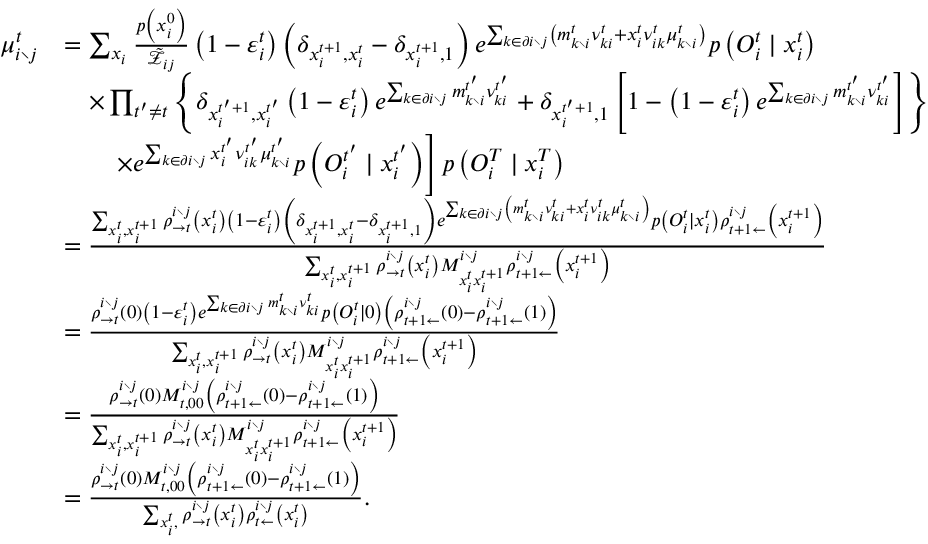Convert formula to latex. <formula><loc_0><loc_0><loc_500><loc_500>\begin{array} { r l } { \mu _ { i \ j } ^ { t } } & { = \sum _ { x _ { i } } \frac { p \left ( x _ { i } ^ { 0 } \right ) } { \tilde { \mathcal { Z } } _ { i j } } \left ( 1 - \varepsilon _ { i } ^ { t } \right ) \left ( \delta _ { x _ { i } ^ { t + 1 } , x _ { i } ^ { t } } - \delta _ { x _ { i } ^ { t + 1 } , 1 } \right ) e ^ { \sum _ { k \in \partial i \ j } \left ( m _ { k \ i } ^ { t } \nu _ { k i } ^ { t } + x _ { i } ^ { t } \nu _ { i k } ^ { t } \mu _ { k \ i } ^ { t } \right ) } p \left ( O _ { i } ^ { t } | x _ { i } ^ { t } \right ) } \\ & { \quad \times \prod _ { t ^ { \prime } \neq t } \left \{ \delta _ { x _ { i } ^ { t ^ { \prime } + 1 } , x _ { i } ^ { t ^ { \prime } } } \left ( 1 - \varepsilon _ { i } ^ { t } \right ) e ^ { \sum _ { k \in \partial i \ j } m _ { k \ i } ^ { t ^ { \prime } } \nu _ { k i } ^ { t ^ { \prime } } } + \delta _ { x _ { i } ^ { t ^ { \prime } + 1 } , 1 } \left [ 1 - \left ( 1 - \varepsilon _ { i } ^ { t } \right ) e ^ { \sum _ { k \in \partial i \ j } m _ { k \ i } ^ { t ^ { \prime } } \nu _ { k i } ^ { t ^ { \prime } } } \right ] \right \} } \\ & { \quad \times e ^ { \sum _ { k \in \partial i \ j } x _ { i } ^ { t ^ { \prime } } \nu _ { i k } ^ { t ^ { \prime } } \mu _ { k \ i } ^ { t ^ { \prime } } } p \left ( O _ { i } ^ { t ^ { \prime } } | x _ { i } ^ { t ^ { \prime } } \right ) \right ] p \left ( { O } _ { i } ^ { T } | x _ { i } ^ { T } \right ) } \\ & { = \frac { \sum _ { x _ { i } ^ { t } , x _ { i } ^ { t + 1 } } \rho _ { \rightarrow t } ^ { i \ j } \left ( x _ { i } ^ { t } \right ) \left ( 1 - \varepsilon _ { i } ^ { t } \right ) \left ( \delta _ { x _ { i } ^ { t + 1 } , x _ { i } ^ { t } } - \delta _ { x _ { i } ^ { t + 1 } , 1 } \right ) e ^ { \sum _ { k \in \partial i \ j } \left ( m _ { k \ i } ^ { t } \nu _ { k i } ^ { t } + x _ { i } ^ { t } \nu _ { i k } ^ { t } \mu _ { k \ i } ^ { t } \right ) } p \left ( O _ { i } ^ { t } | x _ { i } ^ { t } \right ) \rho _ { t + 1 \leftarrow } ^ { i \ j } \left ( x _ { i } ^ { t + 1 } \right ) } { \sum _ { x _ { i } ^ { t } , x _ { i } ^ { t + 1 } } \rho _ { \rightarrow t } ^ { i \ j } \left ( x _ { i } ^ { t } \right ) M _ { x _ { i } ^ { t } x _ { i } ^ { t + 1 } } ^ { i \ j } \rho _ { t + 1 \leftarrow } ^ { i \ j } \left ( x _ { i } ^ { t + 1 } \right ) } } \\ & { = \frac { \rho _ { \rightarrow t } ^ { i \ j } \left ( 0 \right ) \left ( 1 - \varepsilon _ { i } ^ { t } \right ) e ^ { \sum _ { k \in \partial i \ j } m _ { k \ i } ^ { t } \nu _ { k i } ^ { t } } p \left ( O _ { i } ^ { t } | 0 \right ) \left ( \rho _ { t + 1 \leftarrow } ^ { i \ j } \left ( 0 \right ) - \rho _ { t + 1 \leftarrow } ^ { i \ j } \left ( 1 \right ) \right ) } { \sum _ { x _ { i } ^ { t } , x _ { i } ^ { t + 1 } } \rho _ { \rightarrow t } ^ { i \ j } \left ( x _ { i } ^ { t } \right ) M _ { x _ { i } ^ { t } x _ { i } ^ { t + 1 } } ^ { i \ j } \rho _ { t + 1 \leftarrow } ^ { i \ j } \left ( x _ { i } ^ { t + 1 } \right ) } } \\ & { = \frac { \rho _ { \rightarrow t } ^ { i \ j } \left ( 0 \right ) M _ { t , 0 0 } ^ { i \ j } \left ( \rho _ { t + 1 \leftarrow } ^ { i \ j } \left ( 0 \right ) - \rho _ { t + 1 \leftarrow } ^ { i \ j } \left ( 1 \right ) \right ) } { \sum _ { x _ { i } ^ { t } , x _ { i } ^ { t + 1 } } \rho _ { \rightarrow t } ^ { i \ j } \left ( x _ { i } ^ { t } \right ) M _ { x _ { i } ^ { t } x _ { i } ^ { t + 1 } } ^ { i \ j } \rho _ { t + 1 \leftarrow } ^ { i \ j } \left ( x _ { i } ^ { t + 1 } \right ) } } \\ & { = \frac { \rho _ { \rightarrow t } ^ { i \ j } \left ( 0 \right ) M _ { t , 0 0 } ^ { i \ j } \left ( \rho _ { t + 1 \leftarrow } ^ { i \ j } \left ( 0 \right ) - \rho _ { t + 1 \leftarrow } ^ { i \ j } \left ( 1 \right ) \right ) } { \sum _ { x _ { i } ^ { t } , } \rho _ { \rightarrow t } ^ { i \ j } \left ( x _ { i } ^ { t } \right ) \rho _ { t \leftarrow } ^ { i \ j } \left ( x _ { i } ^ { t } \right ) } . } \end{array}</formula> 